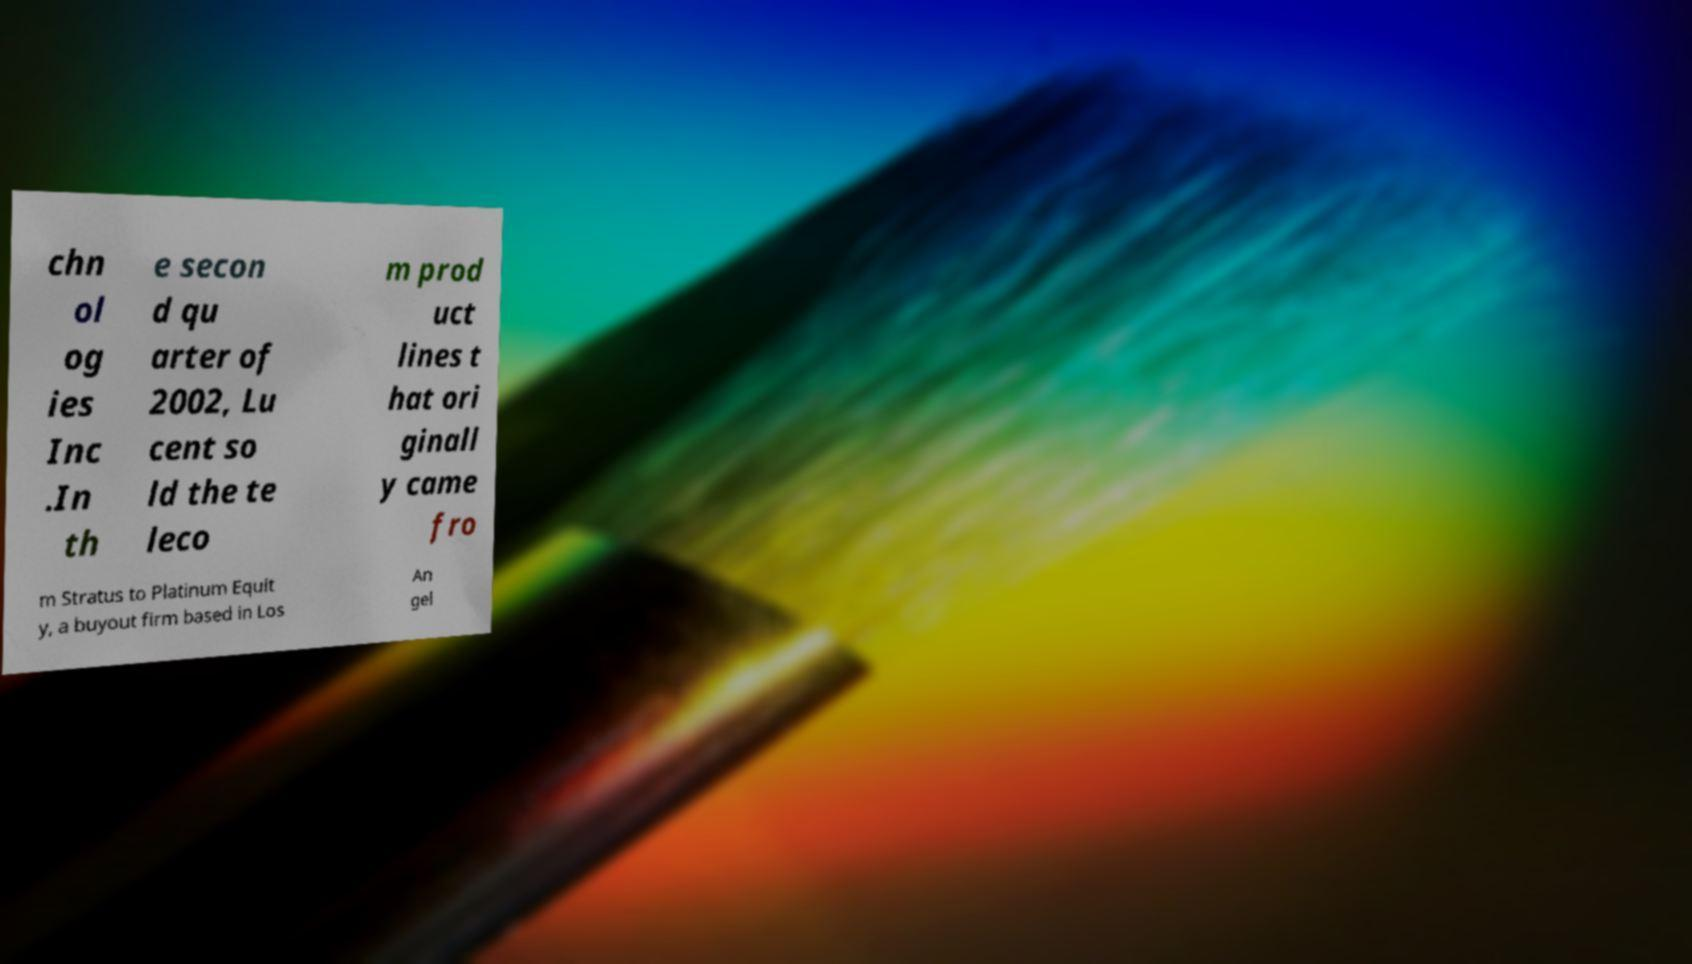What messages or text are displayed in this image? I need them in a readable, typed format. chn ol og ies Inc .In th e secon d qu arter of 2002, Lu cent so ld the te leco m prod uct lines t hat ori ginall y came fro m Stratus to Platinum Equit y, a buyout firm based in Los An gel 